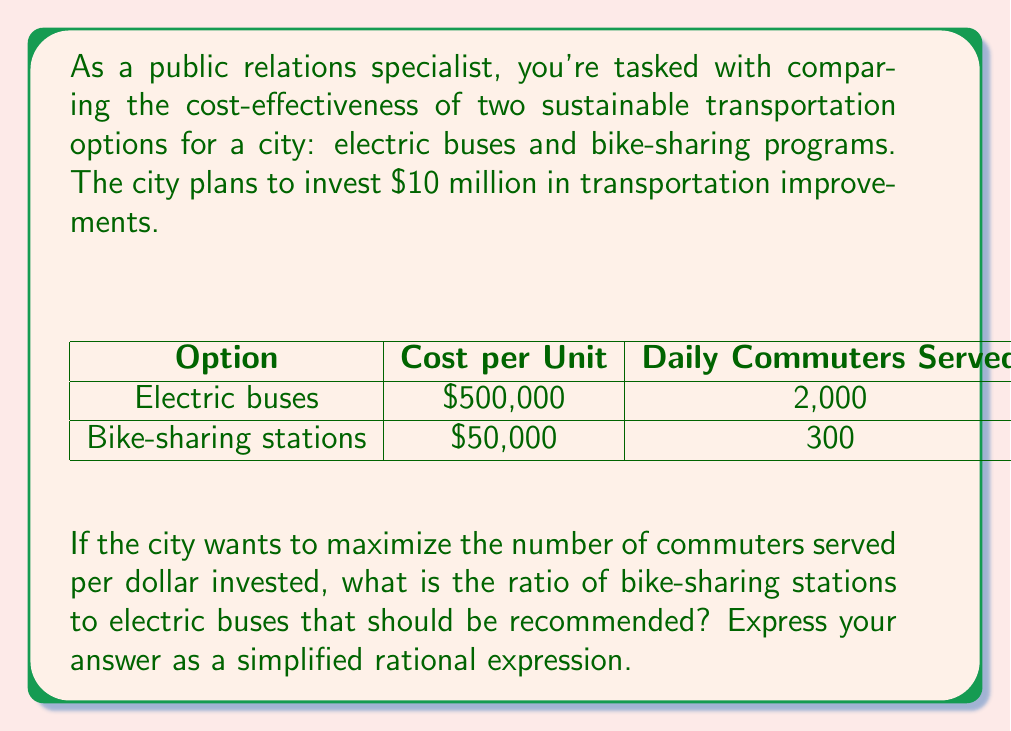Show me your answer to this math problem. Let's approach this step-by-step:

1. Define variables:
   Let $x$ = number of electric buses
   Let $y$ = number of bike-sharing stations

2. Set up the total cost equation:
   $500,000x + 50,000y = 10,000,000$

3. Simplify the equation:
   $10x + y = 200$

4. Calculate the number of commuters served by each option:
   Electric buses: $2,000x$
   Bike-sharing: $300y$

5. To maximize commuters served per dollar, we want to maximize:
   $\frac{2,000x + 300y}{10,000,000}$

6. Simplify this expression:
   $\frac{2,000x + 300y}{10,000,000} = \frac{20x + 3y}{100,000}$

7. To compare the effectiveness, we need to find the ratio of $y$ to $x$ that maximizes this expression.

8. We can do this by setting up a ratio of the coefficients:
   $\frac{y}{x} = \frac{20}{3}$

9. Simplify this ratio:
   $\frac{y}{x} = \frac{20}{3} = \frac{6.67}{1}$

Therefore, for every electric bus, there should be approximately 6.67 bike-sharing stations to maximize cost-effectiveness.
Answer: $\frac{y}{x} = \frac{20}{3}$ 